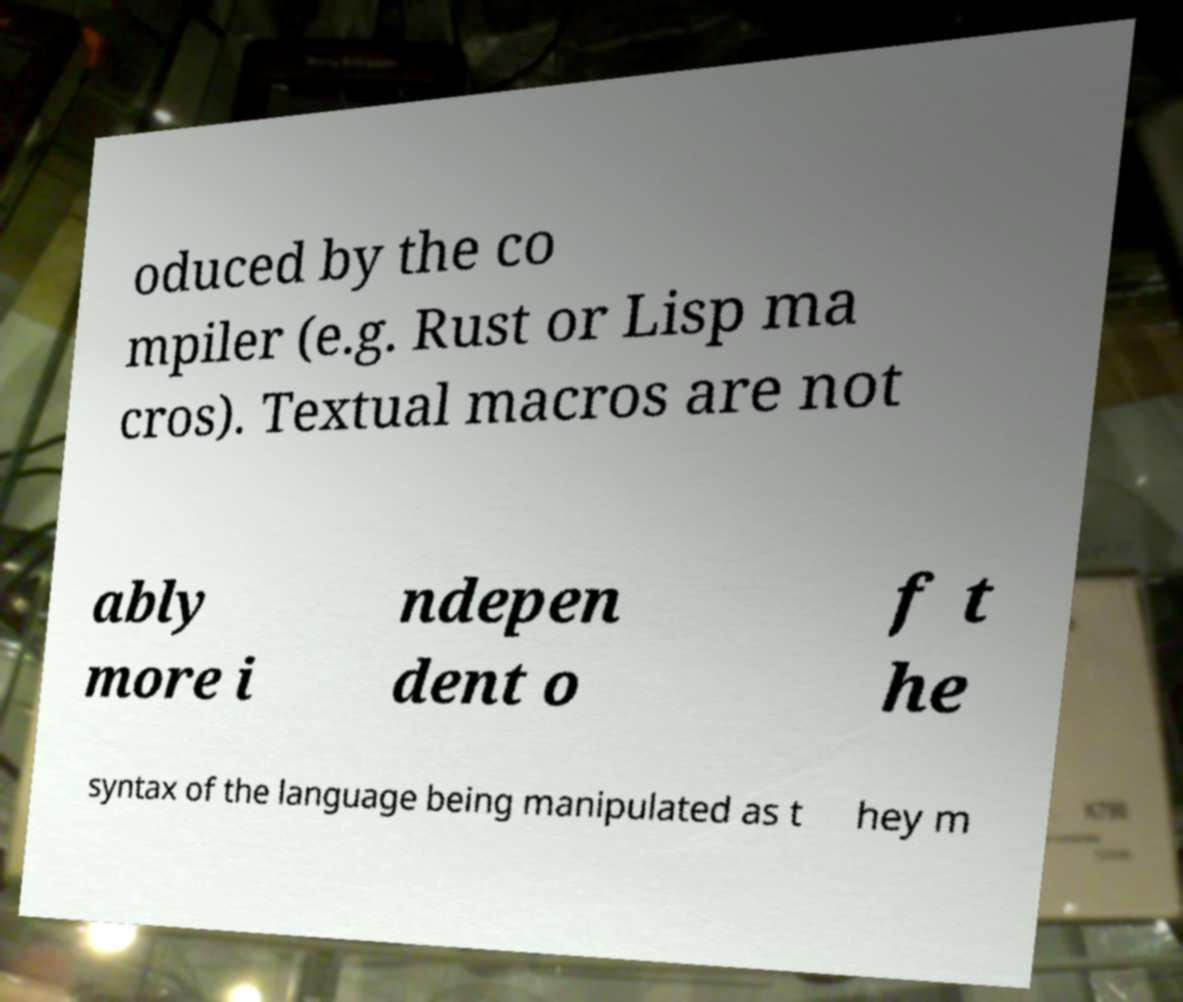There's text embedded in this image that I need extracted. Can you transcribe it verbatim? oduced by the co mpiler (e.g. Rust or Lisp ma cros). Textual macros are not ably more i ndepen dent o f t he syntax of the language being manipulated as t hey m 